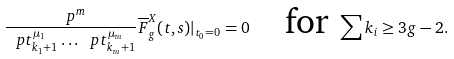<formula> <loc_0><loc_0><loc_500><loc_500>\frac { \ p ^ { m } } { \ p t ^ { \mu _ { 1 } } _ { k _ { 1 } + 1 } \dots \ p t ^ { \mu _ { m } } _ { k _ { m } + 1 } } \overline { F } ^ { X } _ { g } ( t , s ) | _ { t _ { 0 } = 0 } = 0 \quad \text {for} \ \sum k _ { i } \geq 3 g - 2 .</formula> 